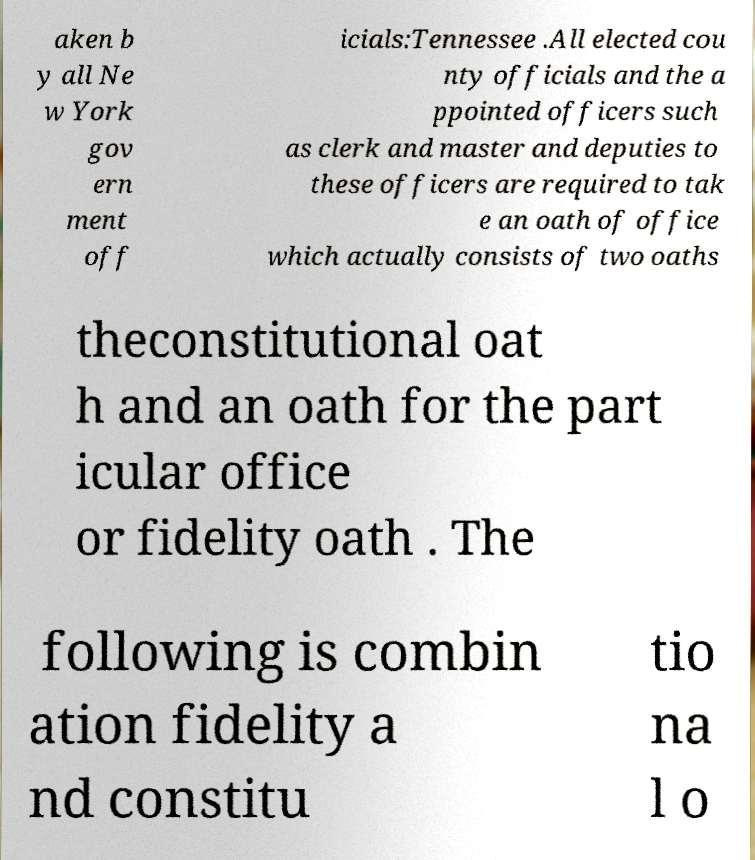Can you read and provide the text displayed in the image?This photo seems to have some interesting text. Can you extract and type it out for me? aken b y all Ne w York gov ern ment off icials:Tennessee .All elected cou nty officials and the a ppointed officers such as clerk and master and deputies to these officers are required to tak e an oath of office which actually consists of two oaths theconstitutional oat h and an oath for the part icular office or fidelity oath . The following is combin ation fidelity a nd constitu tio na l o 